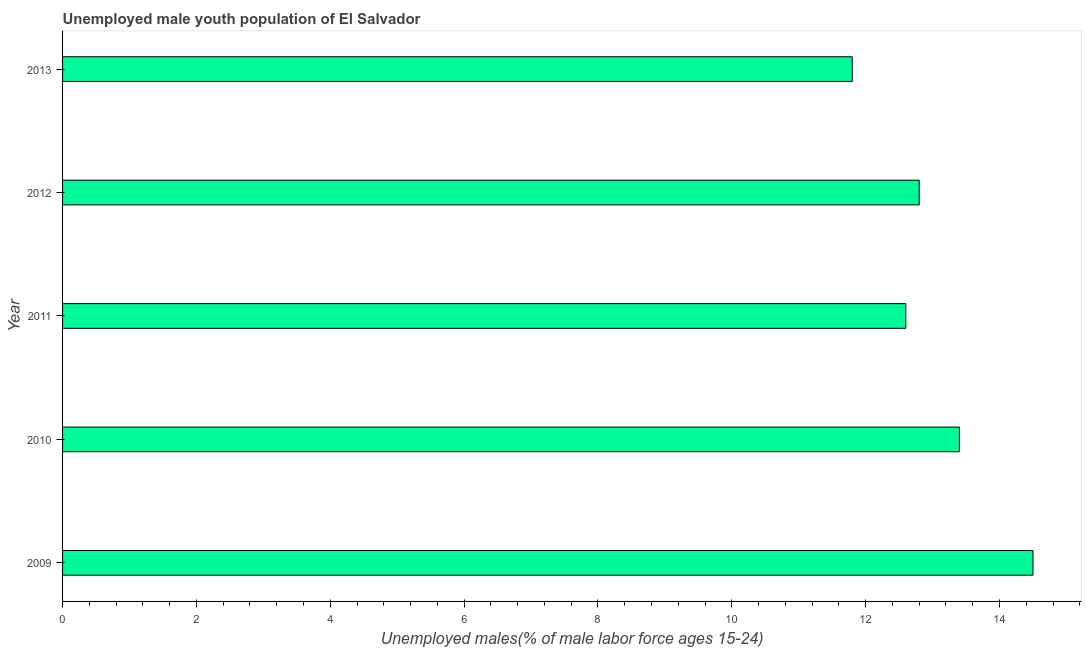What is the title of the graph?
Your answer should be very brief. Unemployed male youth population of El Salvador. What is the label or title of the X-axis?
Provide a succinct answer. Unemployed males(% of male labor force ages 15-24). What is the label or title of the Y-axis?
Make the answer very short. Year. What is the unemployed male youth in 2013?
Provide a short and direct response. 11.8. Across all years, what is the maximum unemployed male youth?
Give a very brief answer. 14.5. Across all years, what is the minimum unemployed male youth?
Your response must be concise. 11.8. In which year was the unemployed male youth maximum?
Offer a terse response. 2009. In which year was the unemployed male youth minimum?
Offer a terse response. 2013. What is the sum of the unemployed male youth?
Keep it short and to the point. 65.1. What is the difference between the unemployed male youth in 2012 and 2013?
Ensure brevity in your answer.  1. What is the average unemployed male youth per year?
Your answer should be compact. 13.02. What is the median unemployed male youth?
Ensure brevity in your answer.  12.8. In how many years, is the unemployed male youth greater than 2.4 %?
Make the answer very short. 5. What is the ratio of the unemployed male youth in 2010 to that in 2013?
Make the answer very short. 1.14. Is the unemployed male youth in 2012 less than that in 2013?
Offer a terse response. No. Is the difference between the unemployed male youth in 2009 and 2011 greater than the difference between any two years?
Give a very brief answer. No. What is the difference between the highest and the second highest unemployed male youth?
Make the answer very short. 1.1. What is the difference between the highest and the lowest unemployed male youth?
Your answer should be compact. 2.7. Are all the bars in the graph horizontal?
Offer a terse response. Yes. How many years are there in the graph?
Make the answer very short. 5. What is the difference between two consecutive major ticks on the X-axis?
Ensure brevity in your answer.  2. What is the Unemployed males(% of male labor force ages 15-24) in 2009?
Your response must be concise. 14.5. What is the Unemployed males(% of male labor force ages 15-24) in 2010?
Keep it short and to the point. 13.4. What is the Unemployed males(% of male labor force ages 15-24) in 2011?
Give a very brief answer. 12.6. What is the Unemployed males(% of male labor force ages 15-24) of 2012?
Provide a succinct answer. 12.8. What is the Unemployed males(% of male labor force ages 15-24) in 2013?
Offer a very short reply. 11.8. What is the difference between the Unemployed males(% of male labor force ages 15-24) in 2009 and 2010?
Your answer should be compact. 1.1. What is the difference between the Unemployed males(% of male labor force ages 15-24) in 2009 and 2011?
Your answer should be very brief. 1.9. What is the difference between the Unemployed males(% of male labor force ages 15-24) in 2009 and 2012?
Your answer should be compact. 1.7. What is the difference between the Unemployed males(% of male labor force ages 15-24) in 2009 and 2013?
Your answer should be very brief. 2.7. What is the difference between the Unemployed males(% of male labor force ages 15-24) in 2010 and 2011?
Ensure brevity in your answer.  0.8. What is the difference between the Unemployed males(% of male labor force ages 15-24) in 2010 and 2012?
Make the answer very short. 0.6. What is the difference between the Unemployed males(% of male labor force ages 15-24) in 2011 and 2012?
Offer a terse response. -0.2. What is the difference between the Unemployed males(% of male labor force ages 15-24) in 2012 and 2013?
Make the answer very short. 1. What is the ratio of the Unemployed males(% of male labor force ages 15-24) in 2009 to that in 2010?
Your answer should be compact. 1.08. What is the ratio of the Unemployed males(% of male labor force ages 15-24) in 2009 to that in 2011?
Give a very brief answer. 1.15. What is the ratio of the Unemployed males(% of male labor force ages 15-24) in 2009 to that in 2012?
Give a very brief answer. 1.13. What is the ratio of the Unemployed males(% of male labor force ages 15-24) in 2009 to that in 2013?
Keep it short and to the point. 1.23. What is the ratio of the Unemployed males(% of male labor force ages 15-24) in 2010 to that in 2011?
Your answer should be very brief. 1.06. What is the ratio of the Unemployed males(% of male labor force ages 15-24) in 2010 to that in 2012?
Give a very brief answer. 1.05. What is the ratio of the Unemployed males(% of male labor force ages 15-24) in 2010 to that in 2013?
Offer a very short reply. 1.14. What is the ratio of the Unemployed males(% of male labor force ages 15-24) in 2011 to that in 2012?
Make the answer very short. 0.98. What is the ratio of the Unemployed males(% of male labor force ages 15-24) in 2011 to that in 2013?
Your answer should be compact. 1.07. What is the ratio of the Unemployed males(% of male labor force ages 15-24) in 2012 to that in 2013?
Offer a terse response. 1.08. 